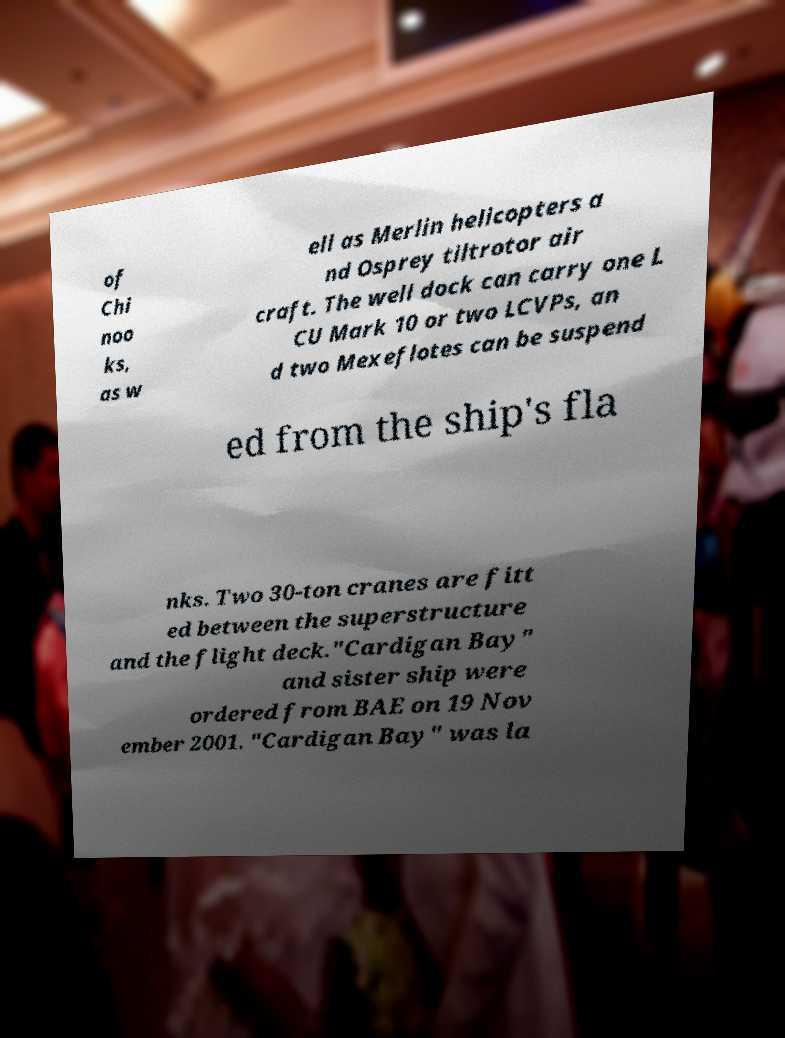Please identify and transcribe the text found in this image. of Chi noo ks, as w ell as Merlin helicopters a nd Osprey tiltrotor air craft. The well dock can carry one L CU Mark 10 or two LCVPs, an d two Mexeflotes can be suspend ed from the ship's fla nks. Two 30-ton cranes are fitt ed between the superstructure and the flight deck."Cardigan Bay" and sister ship were ordered from BAE on 19 Nov ember 2001. "Cardigan Bay" was la 